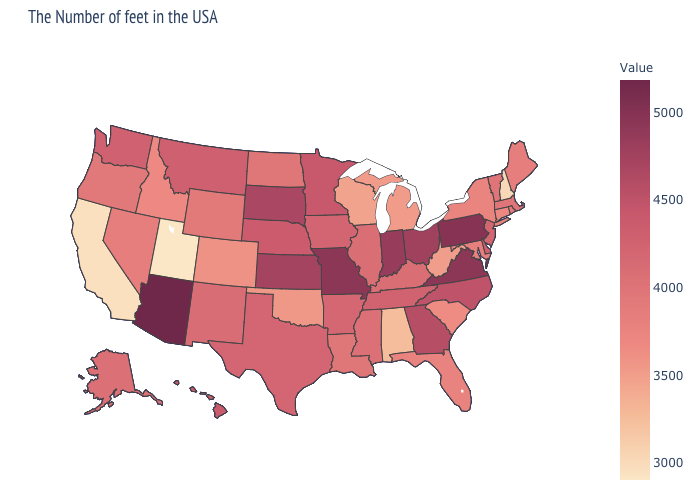Does the map have missing data?
Be succinct. No. Does the map have missing data?
Short answer required. No. Does South Carolina have a lower value than New Mexico?
Be succinct. Yes. 